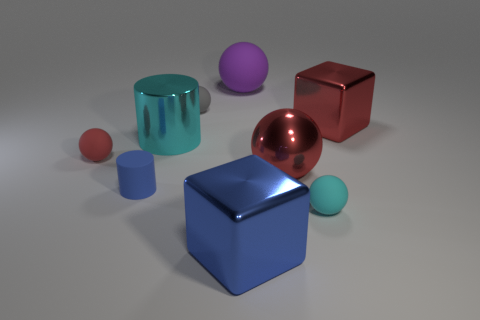There is a big object that is the same color as the big metal sphere; what is it made of?
Give a very brief answer. Metal. What number of big things are red shiny things or yellow rubber balls?
Your response must be concise. 2. There is a matte thing that is the same color as the metal cylinder; what is its shape?
Provide a short and direct response. Sphere. Do the cyan thing behind the tiny cylinder and the tiny cyan sphere have the same material?
Keep it short and to the point. No. What is the material of the small ball that is behind the metallic cube to the right of the small cyan object?
Provide a short and direct response. Rubber. What number of tiny blue matte things are the same shape as the cyan matte object?
Give a very brief answer. 0. There is a cyan object to the left of the small thing on the right side of the cube that is on the left side of the tiny cyan matte object; what size is it?
Offer a very short reply. Large. How many green objects are matte balls or tiny objects?
Your answer should be compact. 0. There is a small thing behind the large red cube; is it the same shape as the purple rubber thing?
Provide a succinct answer. Yes. Is the number of big metal cylinders that are right of the big shiny cylinder greater than the number of balls?
Your response must be concise. No. 